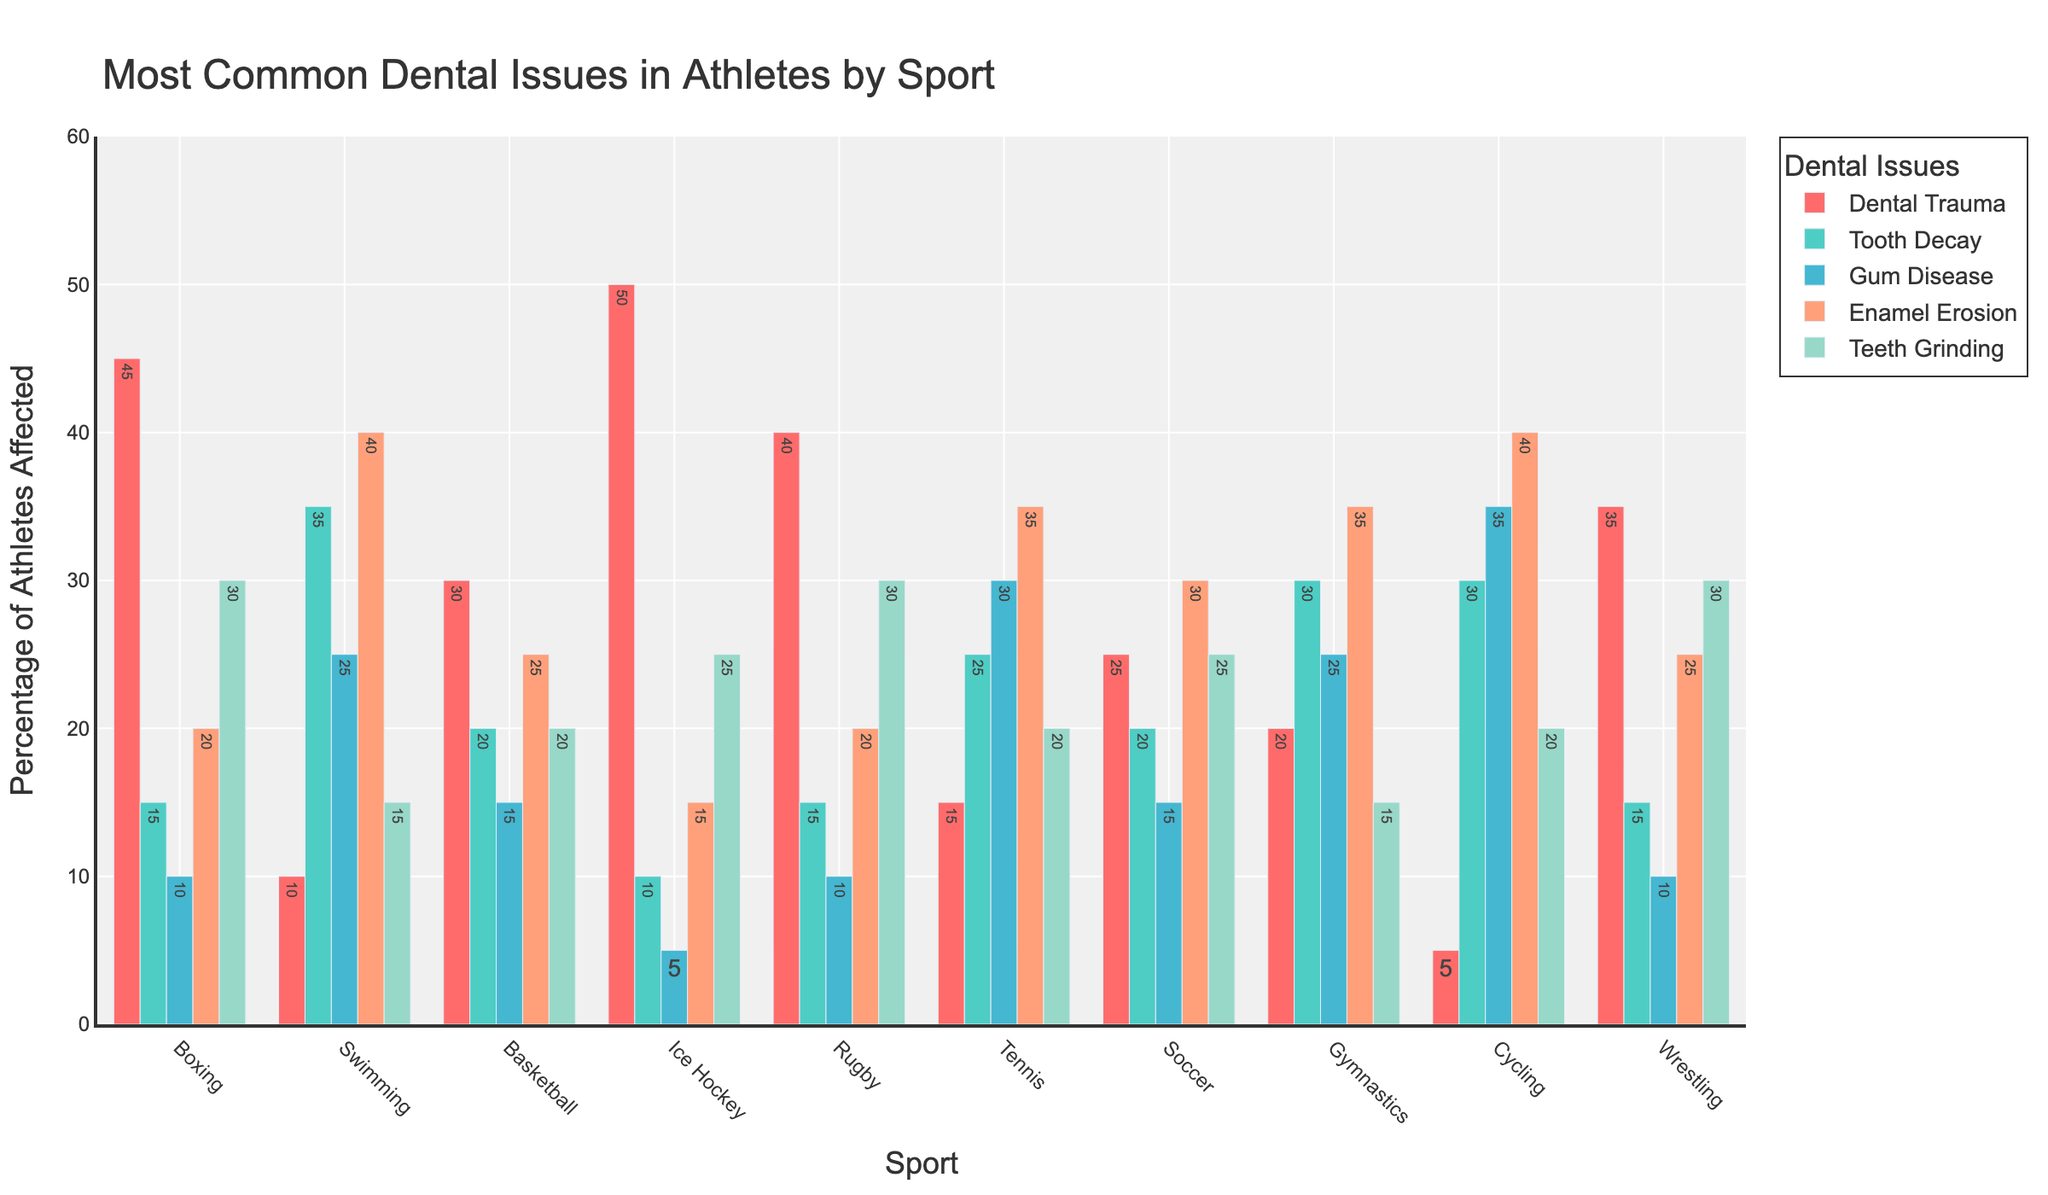What sport has the highest percentage of athletes with dental trauma? By looking at the tallest bar in the dental trauma category (typically in red), you can see that Ice Hockey has the highest percentage with 50%.
Answer: Ice Hockey Which dental issue is most common among swimmers? By comparing the heights of the bars for swimmers, the tallest bar represents enamel erosion at 40%.
Answer: Enamel Erosion How does the percentage of rugby players with dental trauma compare to boxers with the same issue? By looking at the height of the dental trauma bar for rugby players (40%) and for boxers (45%), it's clear that boxers have a slightly higher percentage.
Answer: Boxers with 45%, Rugby with 40% What is the sum of percentages of athletes with gum disease in cycling and wrestling? Look at the gum disease bars for both cycling (35%) and wrestling (10%), then add these percentages together: 35% + 10% = 45%.
Answer: 45% Which sport has the least amount of athletes with tooth decay? By finding the shortest bar in the tooth decay category (typically in green), cycling has the least amount with 5%.
Answer: Cycling What is the difference in the percentage of athletes with enamel erosion between tennis and gymnastics? Compare the heights of the bars representing enamel erosion for tennis (35%) and gymnastics (35%). The difference is 35% - 35% = 0%.
Answer: 0% What sport has the highest combined percentage for dental trauma and teeth grinding? For each sport, add the percentages of dental trauma and teeth grinding. The sport with the highest sum is Boxing with 45% + 30% = 75%.
Answer: Boxing Which dental issue has the most uniform distribution across all sports? By comparing all bars across the sports, tooth decay shows relatively similar bar heights for most sports, indicating a more uniform distribution.
Answer: Tooth Decay How many sports have at least 20% of athletes affected by gum disease? Identify the bars in the gum disease category that meet or exceed 20%. These are Swimming, Tennis, Gymnastics, and Cycling: 4 sports in total.
Answer: 4 